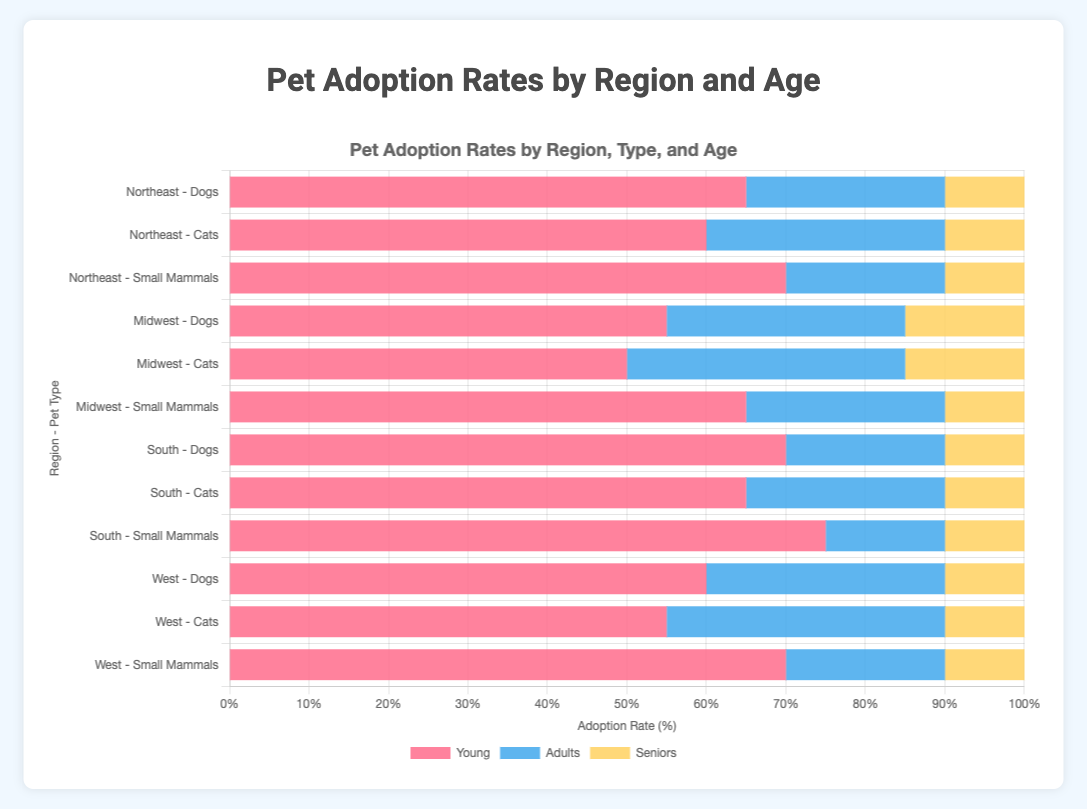Which region has the highest adoption rate for puppies? Look for the highest value in the red bars associated with puppies across all regions. The South region has a stacked bar segment that reaches 70% for puppies.
Answer: South Among dogs, in which region do seniors have the highest adoption rate? Check the yellow bars representing senior dogs across all regions and identify the highest value. The Midwest region shows seniors adoption at 15%.
Answer: Midwest Which type of pet shows the highest adoption rates for young pets in the Midwest? Compare the red bar segments (representing young pets) for Dogs, Cats, and Small Mammals in the Midwest. Small Mammals have the highest rate at 65%.
Answer: Small Mammals Compare the adoption rates of adult cats and adult dogs in the Northeast. Which has a higher rate? Locate the blue segments for adult Cats and Dogs in the Northeast region and compare their values. Cats have 30%, whereas Dogs have 25%.
Answer: Cats What is the difference in adoption rates between puppies in the Northeast and the South? Subtract the adoption rate of puppies in the South (70%) from that in the Northeast (65%). 70 - 65 = 5.
Answer: 5 Which pet region-pair has the lowest senior adoption rate? Identify the smallest yellow bar segment across all regions and types. All regions show a consistent senior adoption rate of 10%, except the Midwest for dogs and cats, which have 15% and are thus excluded. Thus, all regions except the Midwest have the lowest rate of 10% for seniors.
Answer: All except Midwest For Small Mammals in the South, what is the total adoption rate combining all age groups (young, adults, seniors)? Sum the values of the red, blue, and yellow segments for Small Mammals in the South: 75 + 15 + 10 = 100%.
Answer: 100% In the West region, compare the total adoption rates of Dogs and Cats. Which one is higher? Sum the segments for each age group (red, blue, yellow) for Dogs and Cats in the West and compare. Dogs: 60 + 30 + 10 = 100%, Cats: 55 + 35 + 10 = 100%. Both are equal at 100%.
Answer: Equal 